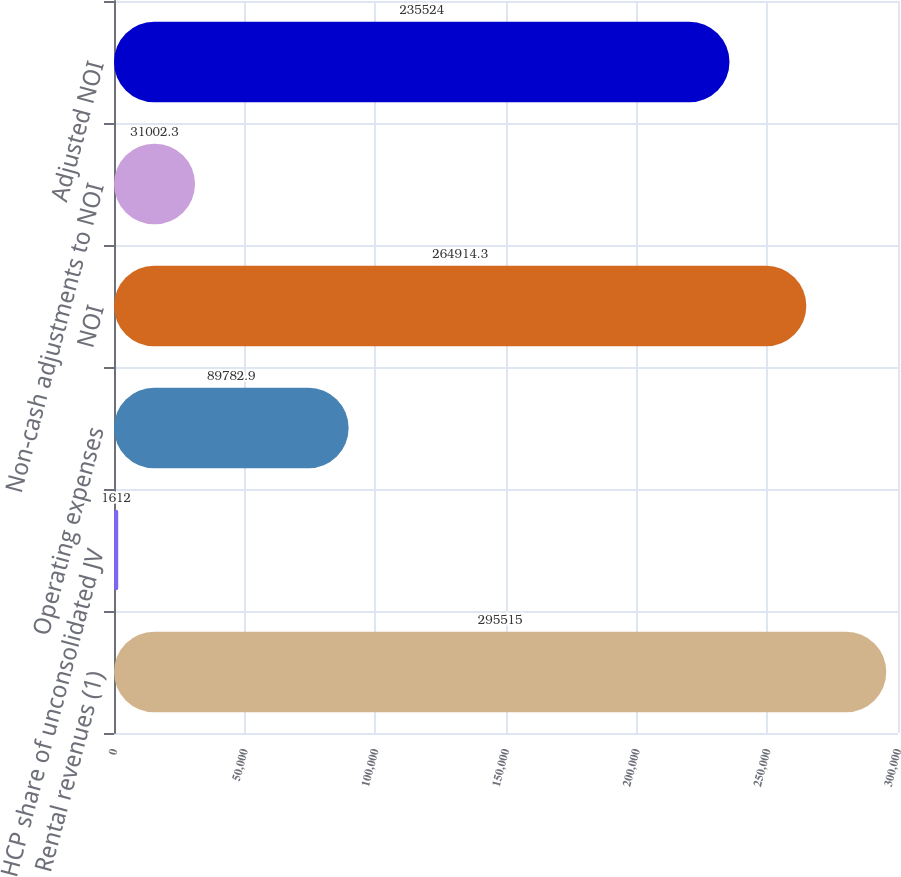Convert chart. <chart><loc_0><loc_0><loc_500><loc_500><bar_chart><fcel>Rental revenues (1)<fcel>HCP share of unconsolidated JV<fcel>Operating expenses<fcel>NOI<fcel>Non-cash adjustments to NOI<fcel>Adjusted NOI<nl><fcel>295515<fcel>1612<fcel>89782.9<fcel>264914<fcel>31002.3<fcel>235524<nl></chart> 